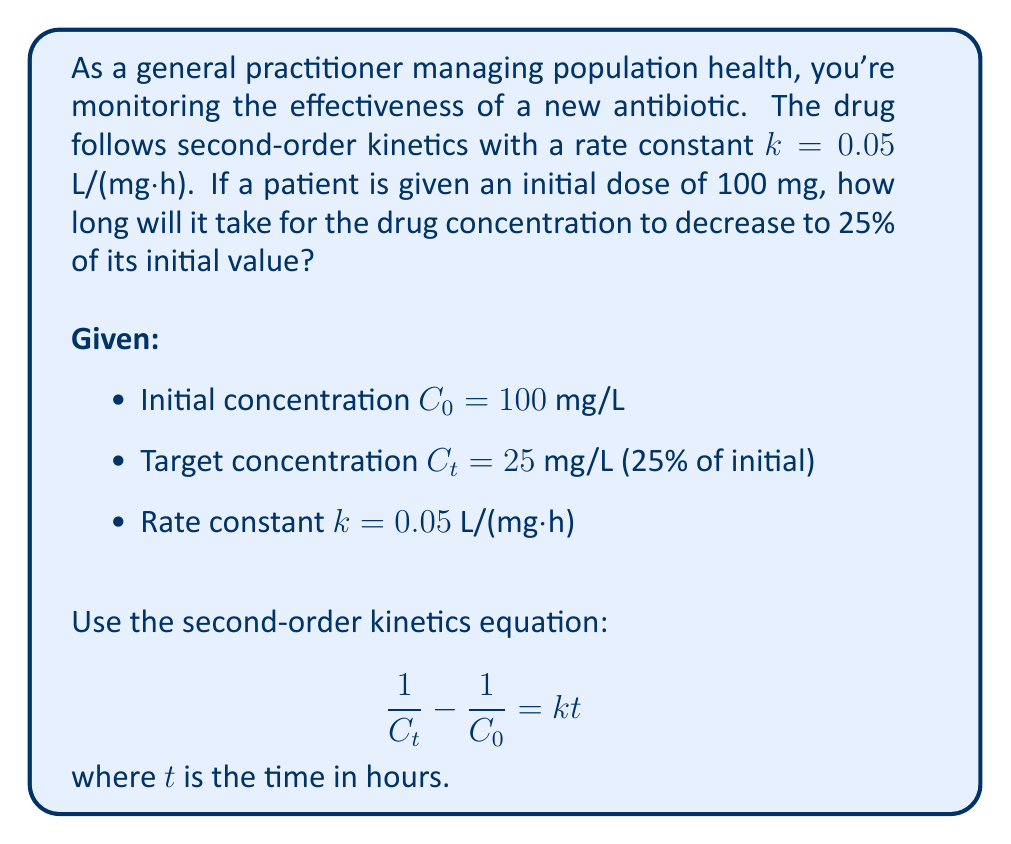Provide a solution to this math problem. Let's solve this problem step by step:

1) We start with the second-order kinetics equation:

   $$\frac{1}{C_t} - \frac{1}{C_0} = kt$$

2) We know:
   $C_0 = 100$ mg/L
   $C_t = 25$ mg/L (25% of 100)
   $k = 0.05$ L/(mg·h)

3) Let's substitute these values into the equation:

   $$\frac{1}{25} - \frac{1}{100} = 0.05t$$

4) Simplify the left side:

   $$0.04 - 0.01 = 0.05t$$
   $$0.03 = 0.05t$$

5) Solve for $t$:

   $$t = \frac{0.03}{0.05} = 0.6$$

Therefore, it will take 0.6 hours for the drug concentration to decrease to 25% of its initial value.

6) Convert to minutes:

   $$0.6 \text{ hours} \times 60 \text{ minutes/hour} = 36 \text{ minutes}$$
Answer: 36 minutes 